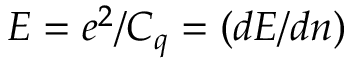<formula> <loc_0><loc_0><loc_500><loc_500>E = e ^ { 2 } / C _ { q } = \left ( d E / d n \right )</formula> 